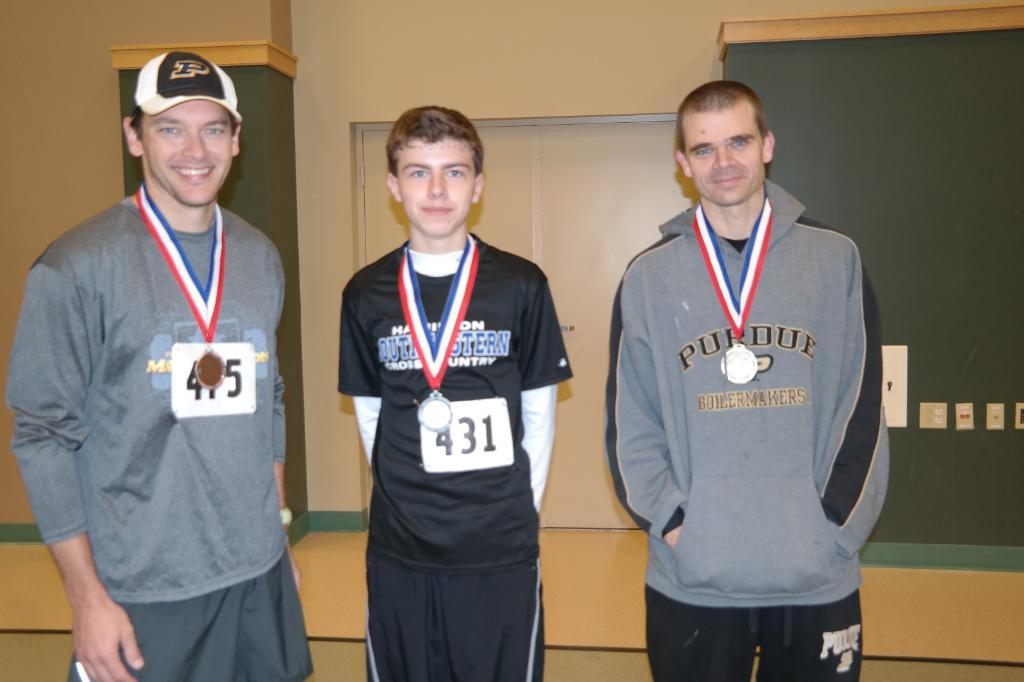<image>
Describe the image concisely. Three award winning athletes with one wearing a gray sweatshirt emblazoned with "Purdue." 